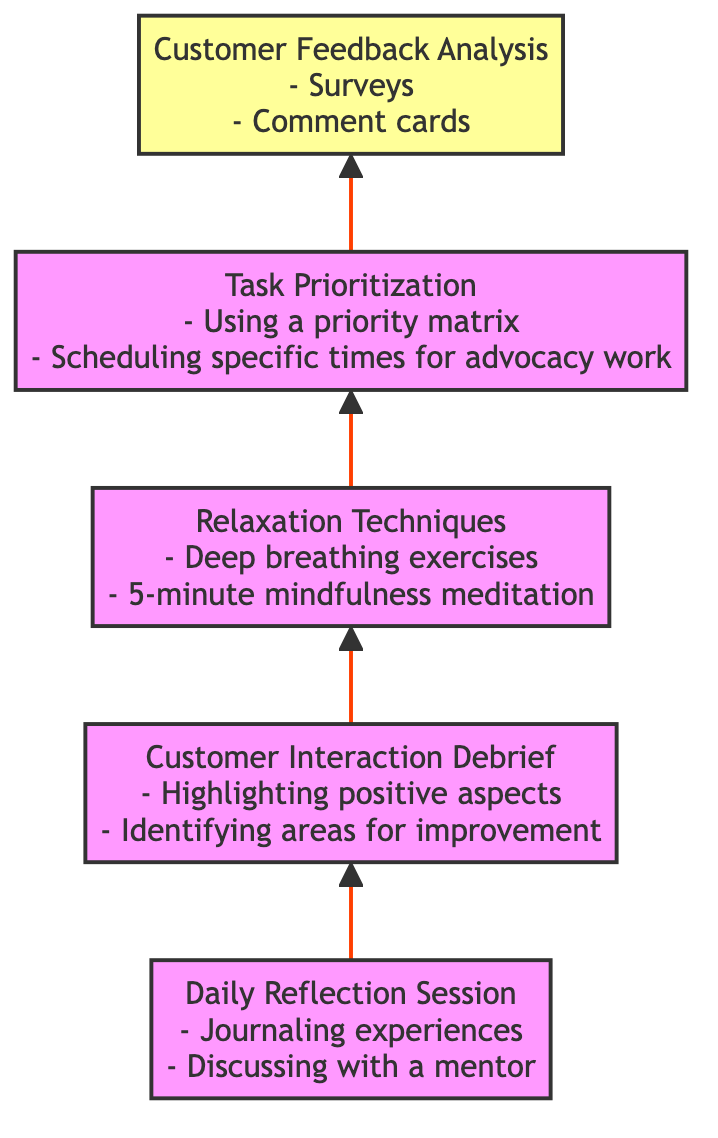What is the last node in the flow chart? The flow chart ends with "Customer Feedback Analysis" as the top-level node, which is the highest point in the structure and indicates the final step in the process.
Answer: Customer Feedback Analysis How many nodes are in the diagram? There are five nodes present in the diagram, each one representing a step in managing stress levels from customer interactions.
Answer: 5 What is the first step in the flow chart? The first step in the flow chart is "Daily Reflection Session," as it is located at the bottom and initiates the flow upwards through the subsequent steps.
Answer: Daily Reflection Session Which nodes lead to "Task Prioritization"? The nodes leading to "Task Prioritization" are "Relaxation Techniques" and "Customer Interaction Debrief," as they both directly connect to it according to the flow of the diagram.
Answer: Relaxation Techniques, Customer Interaction Debrief What is the main purpose of "Customer Feedback Analysis"? "Customer Feedback Analysis" aims to regularly review feedback to gain insights and improve interaction strategies, as indicated in the description of the node.
Answer: Improve interaction strategies How many interactions need to be completed before reaching "Customer Feedback Analysis"? To reach "Customer Feedback Analysis," four interactions need to be completed: "Daily Reflection Session," "Customer Interaction Debrief," "Relaxation Techniques," and "Task Prioritization." Each step precedes the next in the upward flow.
Answer: 4 What is a recommended method in "Relaxation Techniques"? One recommended method in "Relaxation Techniques" is "Deep breathing exercises," which is provided as an example illustrating how to manage stress during customer interactions.
Answer: Deep breathing exercises What is the relationship between "Customer Interaction Debrief" and "Daily Reflection Session"? "Customer Interaction Debrief" follows "Daily Reflection Session" in the flow, indicating that it is a subsequent step focused on analyzing and improving from previous interactions.
Answer: Subsequent step 